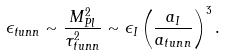Convert formula to latex. <formula><loc_0><loc_0><loc_500><loc_500>\epsilon _ { t u n n } \sim \frac { M _ { P l } ^ { 2 } } { \tau _ { t u n n } ^ { 2 } } \sim \epsilon _ { I } \left ( \frac { a _ { I } } { a _ { t u n n } } \right ) ^ { 3 } .</formula> 